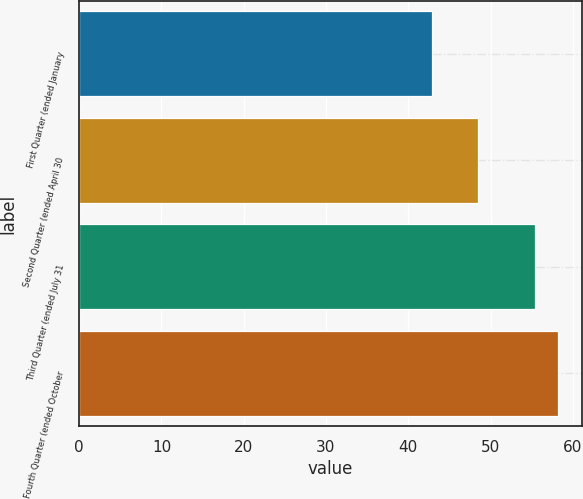Convert chart to OTSL. <chart><loc_0><loc_0><loc_500><loc_500><bar_chart><fcel>First Quarter (ended January<fcel>Second Quarter (ended April 30<fcel>Third Quarter (ended July 31<fcel>Fourth Quarter (ended October<nl><fcel>42.92<fcel>48.47<fcel>55.36<fcel>58.22<nl></chart> 